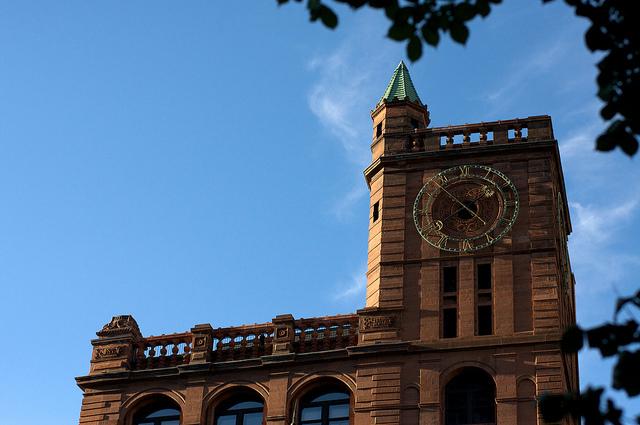Do you see a sign?
Quick response, please. No. Is it going to rain?
Be succinct. No. Where is the picture taken from?
Concise answer only. Ground. Are there leaves on the trees?
Write a very short answer. Yes. Is this a church tower?
Be succinct. Yes. What is on top of this tower?
Answer briefly. Clock. How many clocks are visible?
Answer briefly. 1. What time is it according to the clock in the picture?
Short answer required. 1:40. 